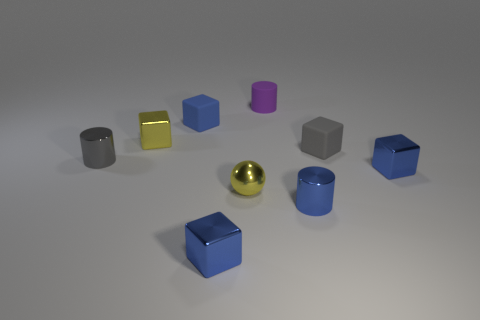Is the material of the gray cube the same as the purple object?
Make the answer very short. Yes. The tiny gray object that is right of the small yellow shiny thing that is left of the small blue metallic block to the left of the purple cylinder is what shape?
Keep it short and to the point. Cube. Is the number of blue cylinders that are to the left of the purple rubber cylinder less than the number of metal cylinders behind the sphere?
Your answer should be very brief. Yes. There is a gray thing right of the small metal cylinder in front of the small gray cylinder; what is its shape?
Offer a terse response. Cube. Is there any other thing that is the same color as the small rubber cylinder?
Ensure brevity in your answer.  No. Is the matte cylinder the same color as the ball?
Make the answer very short. No. What number of blue things are metal spheres or blocks?
Keep it short and to the point. 3. Is the number of small purple objects that are to the right of the tiny blue matte cube less than the number of gray cylinders?
Provide a succinct answer. No. What number of tiny yellow metal spheres are on the right side of the metal cylinder that is to the right of the purple matte cylinder?
Offer a very short reply. 0. What number of other objects are the same size as the gray matte block?
Offer a terse response. 8. 